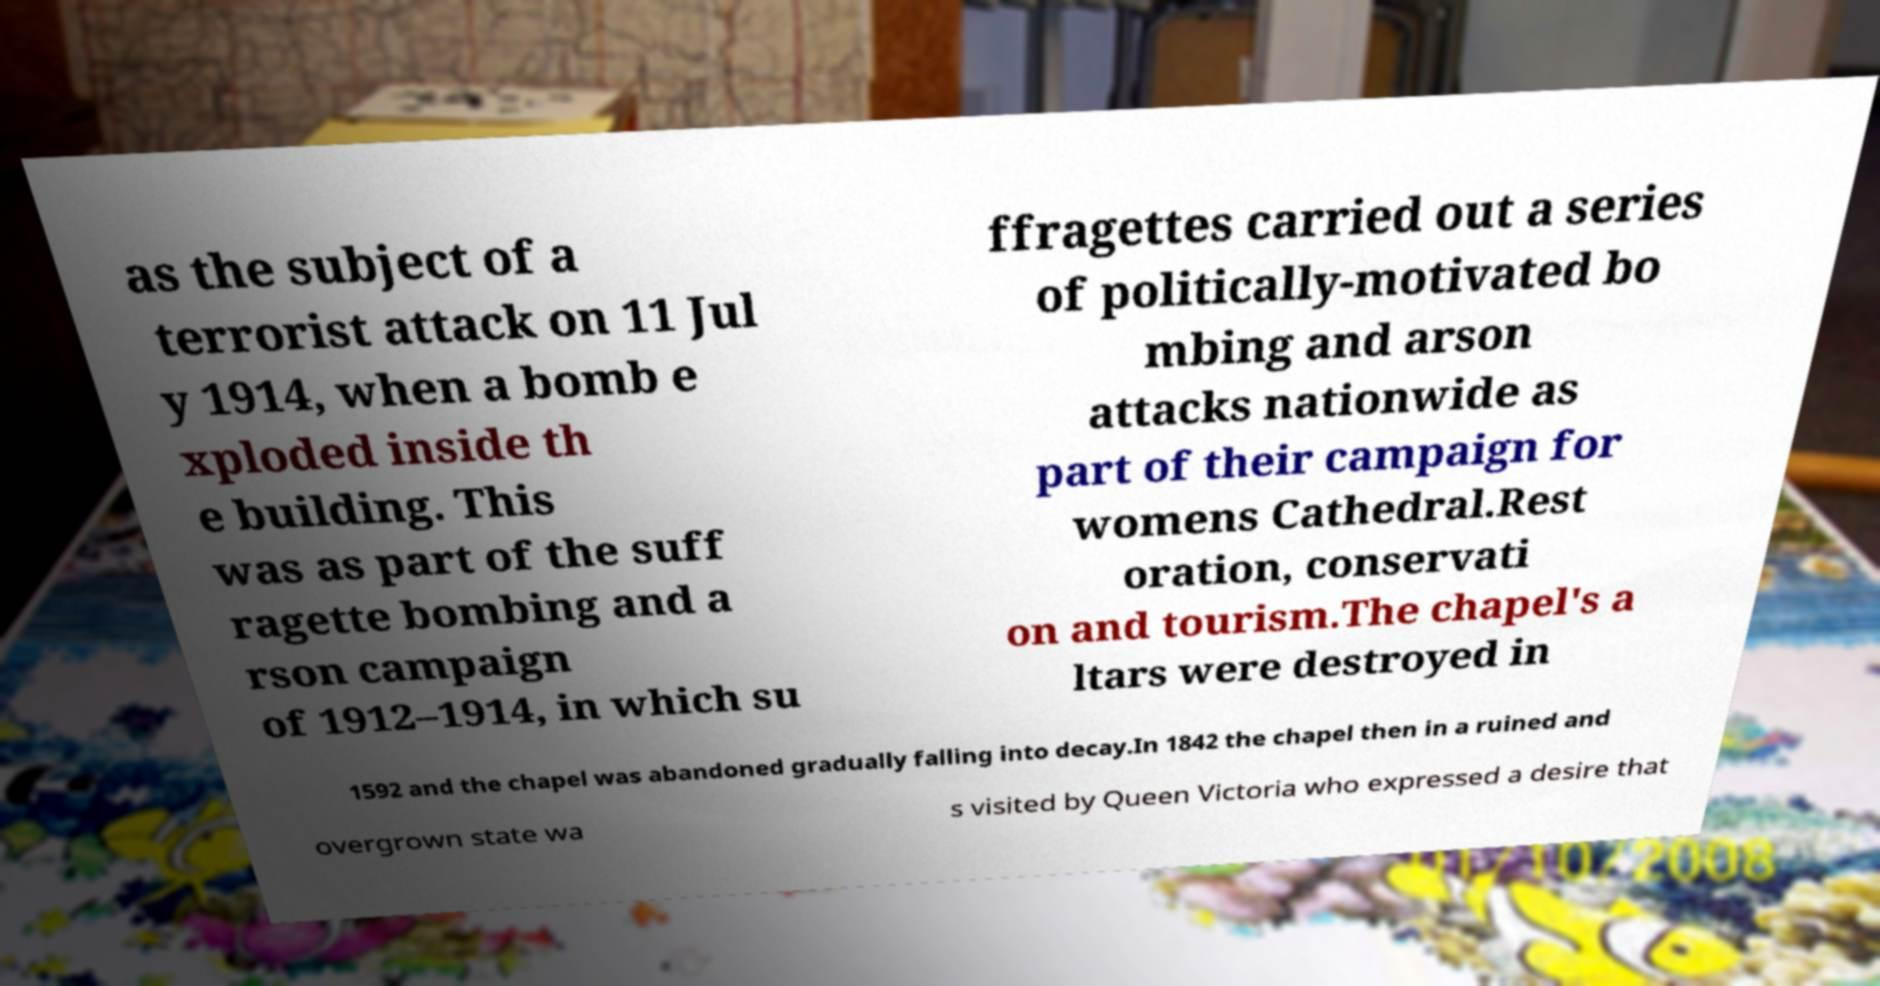Please read and relay the text visible in this image. What does it say? as the subject of a terrorist attack on 11 Jul y 1914, when a bomb e xploded inside th e building. This was as part of the suff ragette bombing and a rson campaign of 1912–1914, in which su ffragettes carried out a series of politically-motivated bo mbing and arson attacks nationwide as part of their campaign for womens Cathedral.Rest oration, conservati on and tourism.The chapel's a ltars were destroyed in 1592 and the chapel was abandoned gradually falling into decay.In 1842 the chapel then in a ruined and overgrown state wa s visited by Queen Victoria who expressed a desire that 